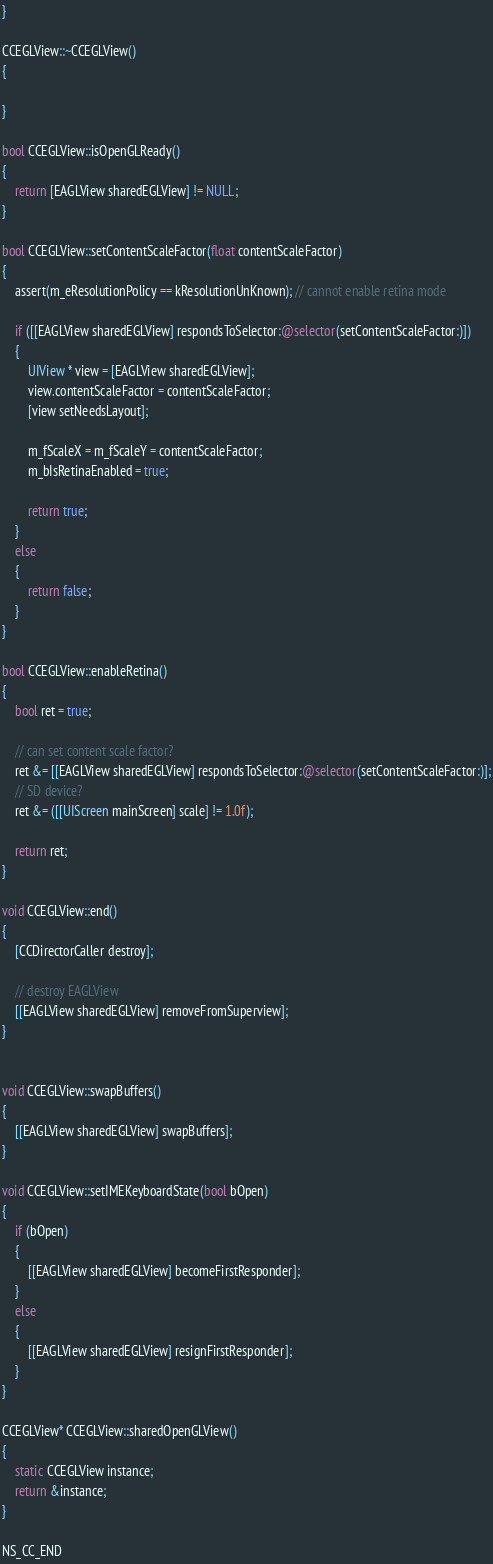Convert code to text. <code><loc_0><loc_0><loc_500><loc_500><_ObjectiveC_>}

CCEGLView::~CCEGLView()
{

}

bool CCEGLView::isOpenGLReady()
{
    return [EAGLView sharedEGLView] != NULL;
}
    
bool CCEGLView::setContentScaleFactor(float contentScaleFactor)
{
    assert(m_eResolutionPolicy == kResolutionUnKnown); // cannot enable retina mode
    
    if ([[EAGLView sharedEGLView] respondsToSelector:@selector(setContentScaleFactor:)])
    {
        UIView * view = [EAGLView sharedEGLView];
        view.contentScaleFactor = contentScaleFactor;
        [view setNeedsLayout];
        
        m_fScaleX = m_fScaleY = contentScaleFactor;
        m_bIsRetinaEnabled = true;
        
        return true;
    }
    else 
    {
        return false;
    }
}

bool CCEGLView::enableRetina()
{
    bool ret = true;
    
    // can set content scale factor?
    ret &= [[EAGLView sharedEGLView] respondsToSelector:@selector(setContentScaleFactor:)];
    // SD device?
    ret &= ([[UIScreen mainScreen] scale] != 1.0f);
    
    return ret;
}

void CCEGLView::end()
{
    [CCDirectorCaller destroy];
    
    // destroy EAGLView
    [[EAGLView sharedEGLView] removeFromSuperview];
}


void CCEGLView::swapBuffers()
{
    [[EAGLView sharedEGLView] swapBuffers];
}

void CCEGLView::setIMEKeyboardState(bool bOpen)
{
    if (bOpen)
    {
        [[EAGLView sharedEGLView] becomeFirstResponder];
    }
    else
    {
        [[EAGLView sharedEGLView] resignFirstResponder];
    }
}

CCEGLView* CCEGLView::sharedOpenGLView()
{
    static CCEGLView instance;
    return &instance;
}

NS_CC_END

</code> 